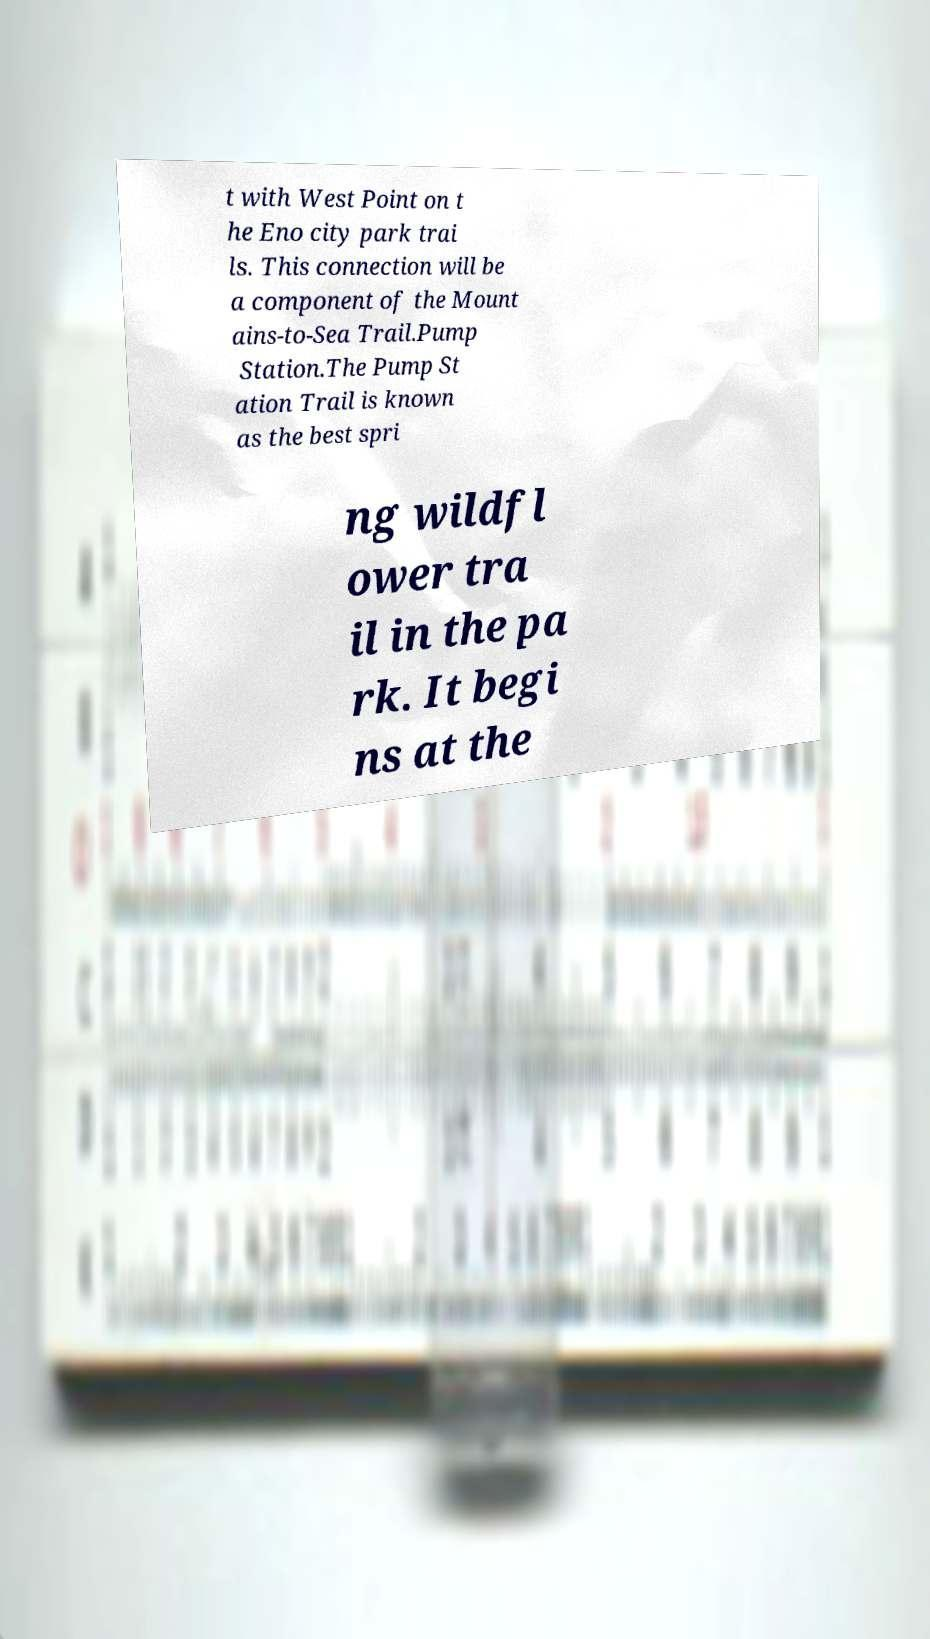I need the written content from this picture converted into text. Can you do that? t with West Point on t he Eno city park trai ls. This connection will be a component of the Mount ains-to-Sea Trail.Pump Station.The Pump St ation Trail is known as the best spri ng wildfl ower tra il in the pa rk. It begi ns at the 